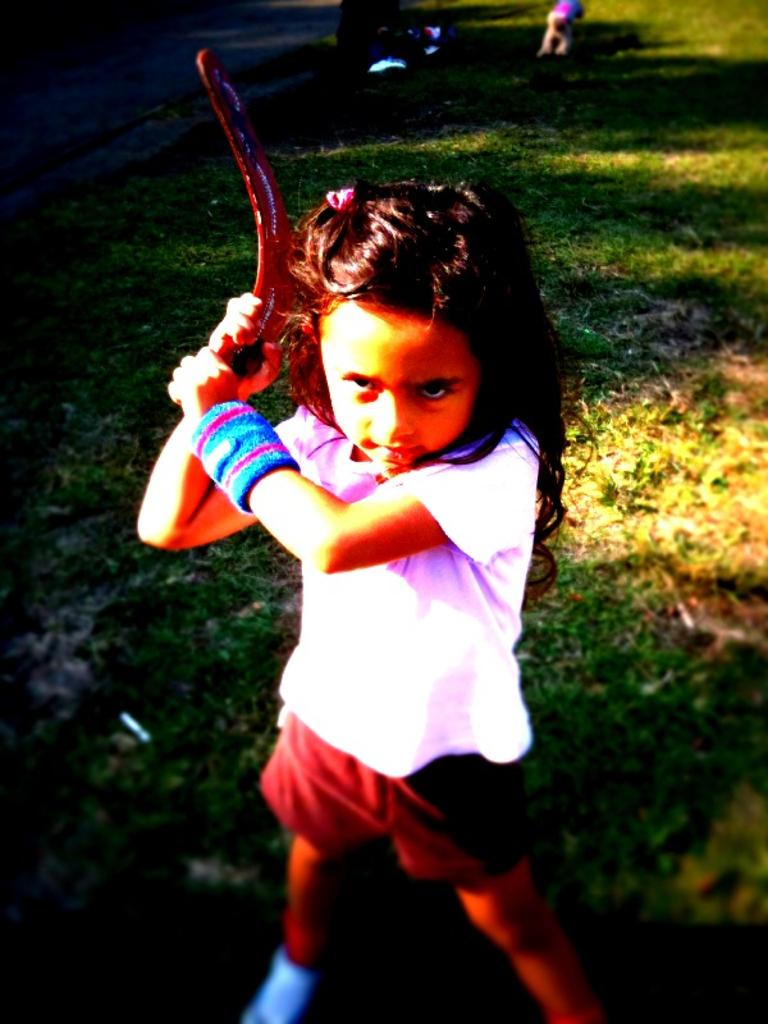Who is the main subject in the image? There is a girl in the image. What is the girl wearing? The girl is wearing a white t-shirt and shorts. What is the girl holding in her hand? The girl is holding an object in her hand. What can be seen in the background of the image? There is grass in the background of the image. What type of soap is the girl using to grip the object in the image? There is no soap present in the image, and the girl is not using any soap to grip the object. Can you see a plane flying in the background of the image? There is no plane visible in the background of the image; it features grass instead. 